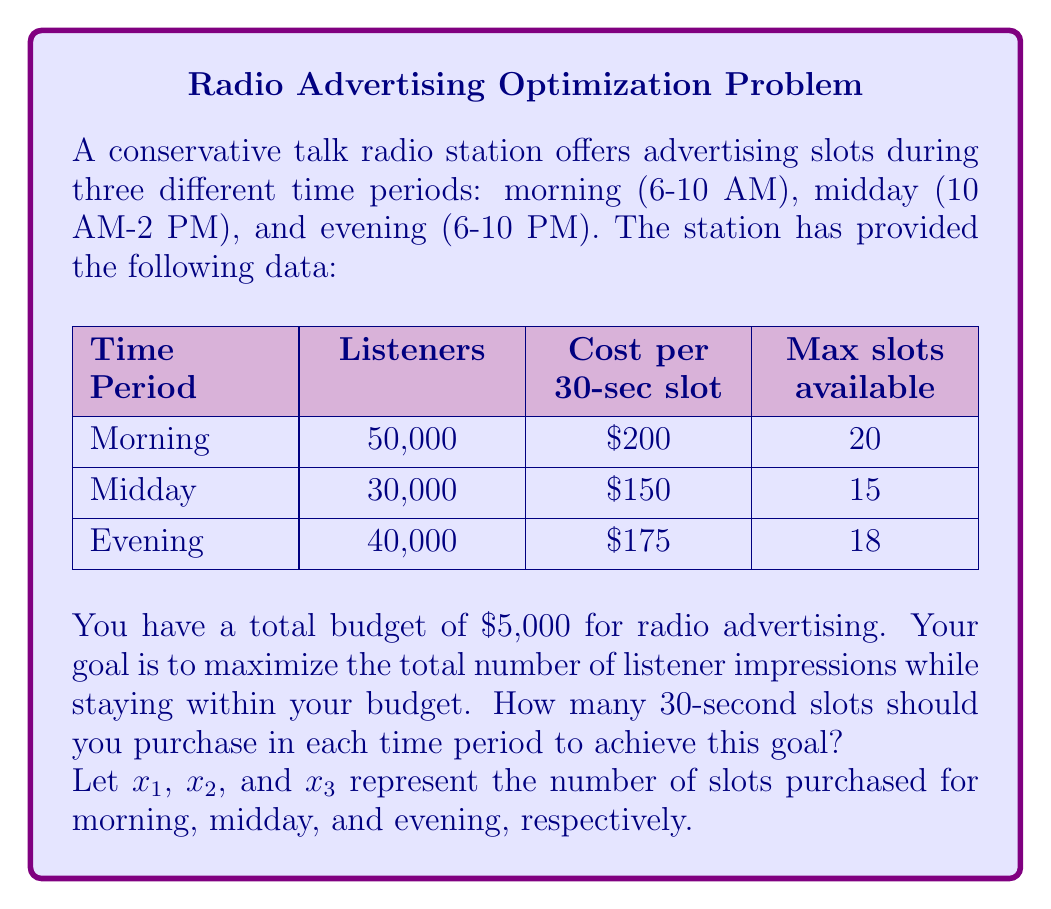Help me with this question. To solve this problem, we'll use linear programming. Our objective is to maximize the total number of listener impressions while staying within the budget and slot availability constraints.

1. Objective function:
   Maximize $Z = 50000x_1 + 30000x_2 + 40000x_3$

2. Constraints:
   Budget: $200x_1 + 150x_2 + 175x_3 \leq 5000$
   Morning slots: $x_1 \leq 20$
   Midday slots: $x_2 \leq 15$
   Evening slots: $x_3 \leq 18$
   Non-negativity: $x_1, x_2, x_3 \geq 0$

3. Solving the linear programming problem:

   We can solve this using the simplex method or a solver. However, we can also use a heuristic approach given the problem's structure:

   a) Calculate the listener-to-cost ratio for each time slot:
      Morning: $50000 / 200 = 250$ listeners/$
      Midday: $30000 / 150 = 200$ listeners/$
      Evening: $40000 / 175 \approx 228.57$ listeners/$

   b) Allocate budget to slots in order of highest ratio to lowest:

      Morning (250 listeners/$):
      $20 * 200 = 4000$ (max slots)
      Budget left: $5000 - 4000 = 1000$

      Evening (228.57 listeners/$):
      $1000 / 175 \approx 5.71$ slots
      Round down to 5 slots: $5 * 175 = 875$
      Budget left: $1000 - 875 = 125$

      Midday (200 listeners/$):
      $125 / 150 \approx 0.83$ slots
      Round down to 0 slots

4. Final allocation:
   Morning ($x_1$): 20 slots
   Midday ($x_2$): 0 slots
   Evening ($x_3$): 5 slots

5. Verify constraints:
   Budget: $200(20) + 150(0) + 175(5) = 4000 + 0 + 875 = 4875 \leq 5000$
   All slot constraints are satisfied.

6. Calculate total listener impressions:
   $Z = 50000(20) + 30000(0) + 40000(5) = 1,000,000 + 0 + 200,000 = 1,200,000$
Answer: The optimal allocation is:
Morning: 20 slots
Midday: 0 slots
Evening: 5 slots
This allocation results in 1,200,000 listener impressions while using $4,875 of the $5,000 budget. 